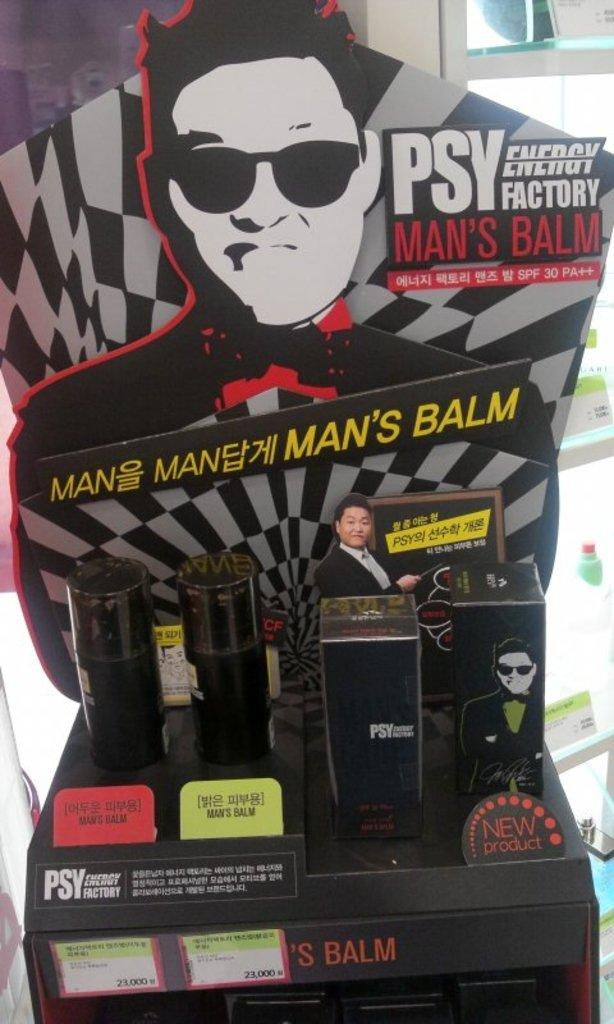<image>
Write a terse but informative summary of the picture. a poster of a man's balm advertisement with cards 